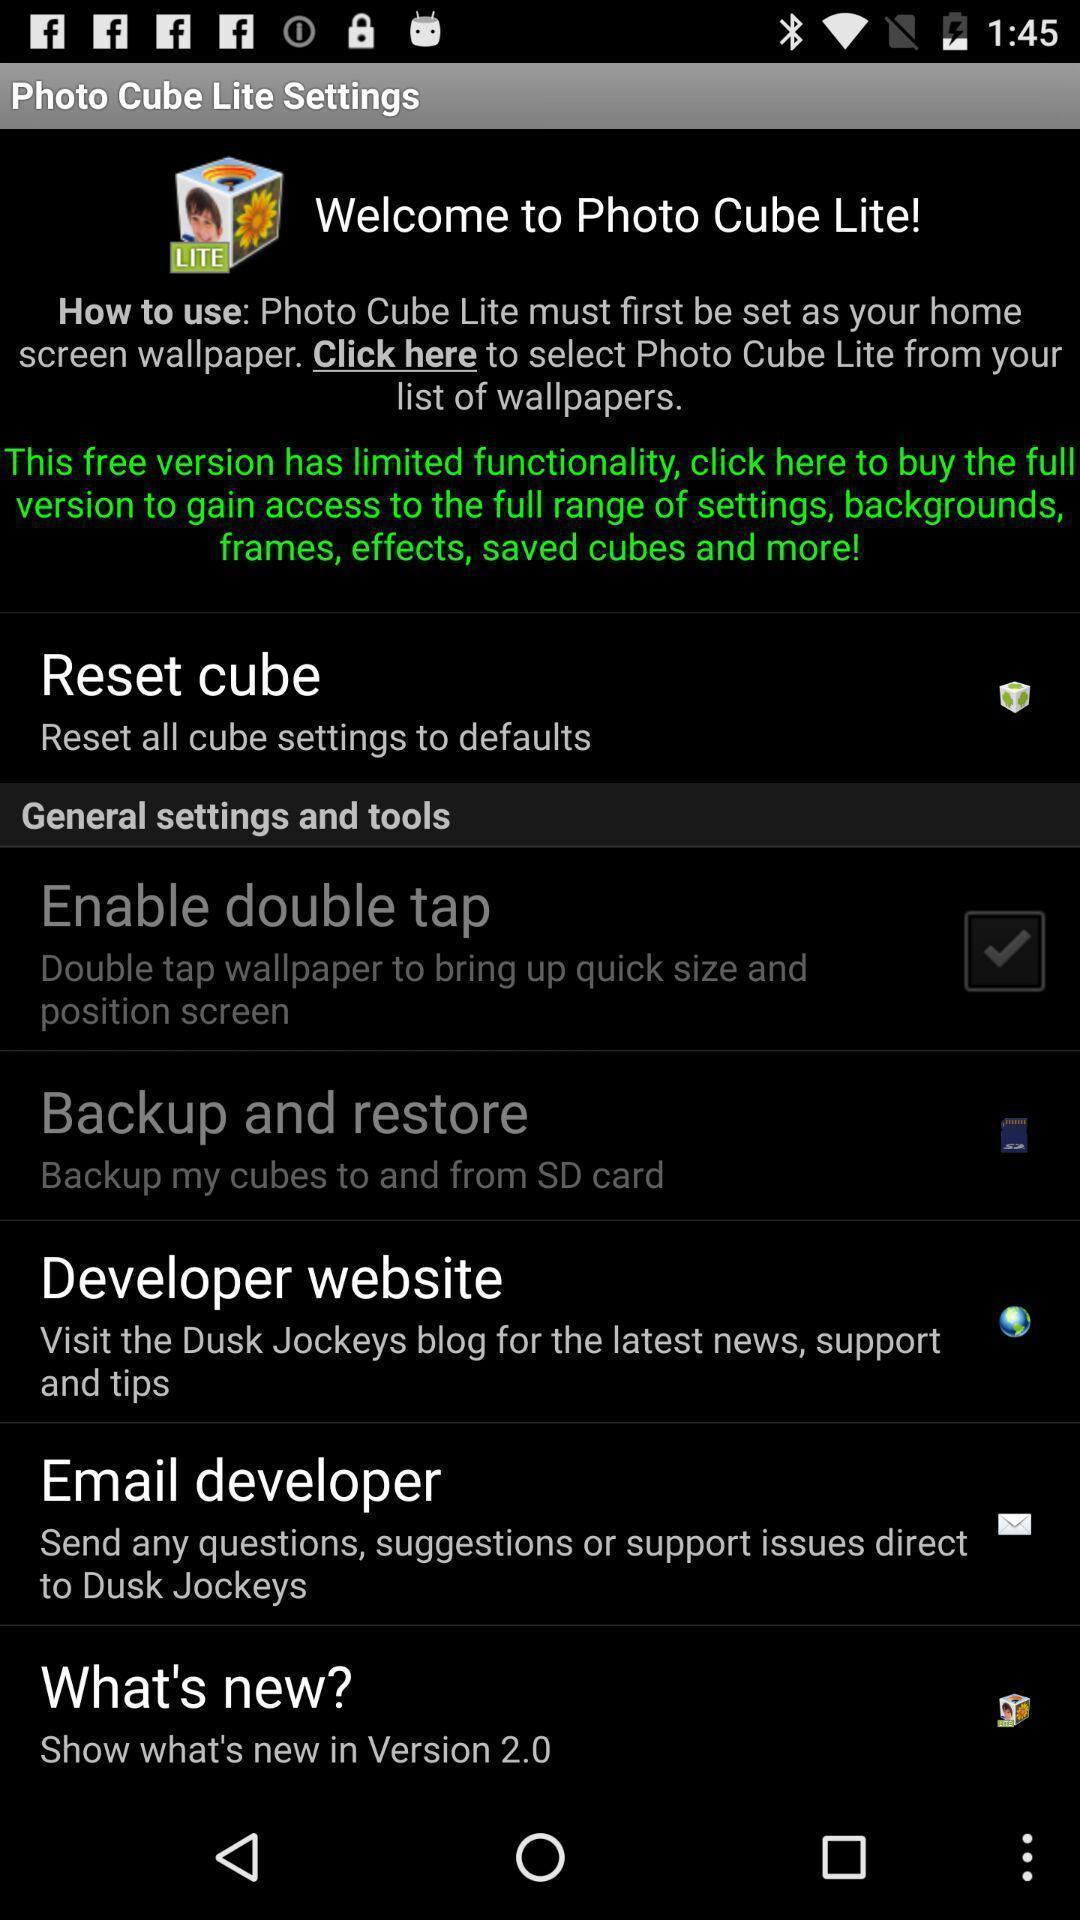Provide a detailed account of this screenshot. Welcoming page of photo cube. 